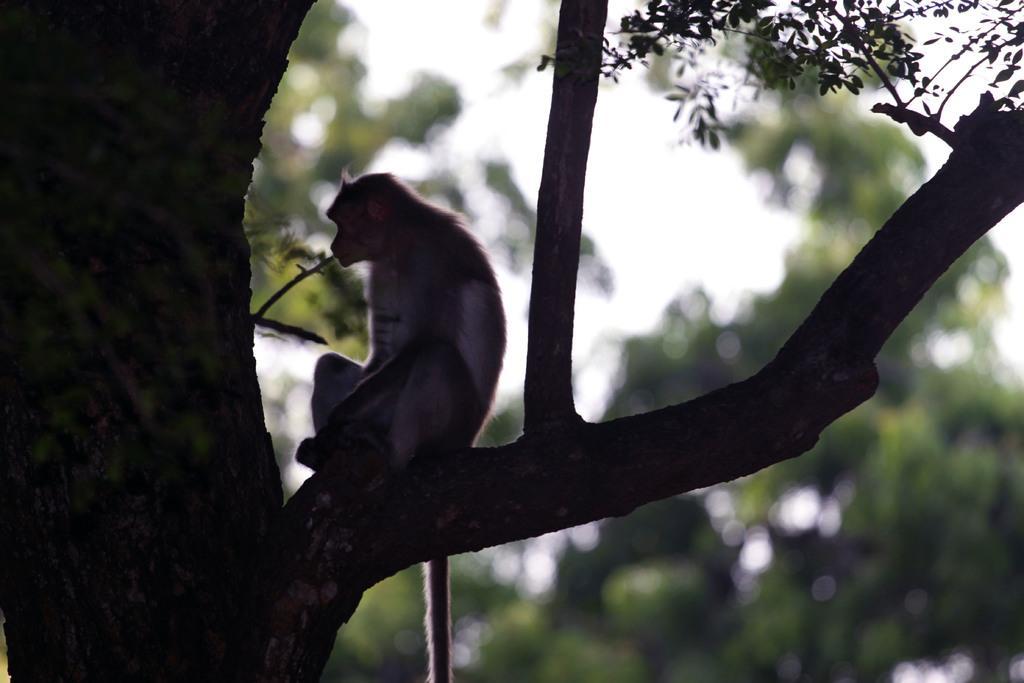Can you describe this image briefly? In this image I can see a monkey is sitting on the branch of a tree, the sky and trees. This image is taken may be in the forest. 